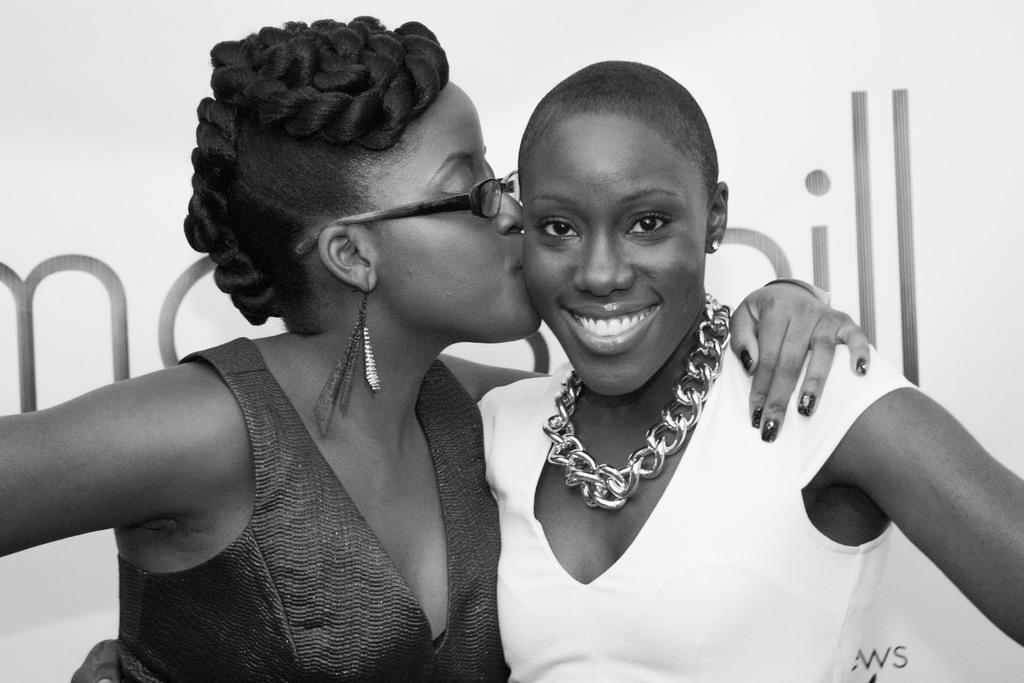Can you describe this image briefly? In this image there are women. On the right side there is a woman standing and smiling and on the left side there is a woman standing and in the background there is a board with some text written on it. 